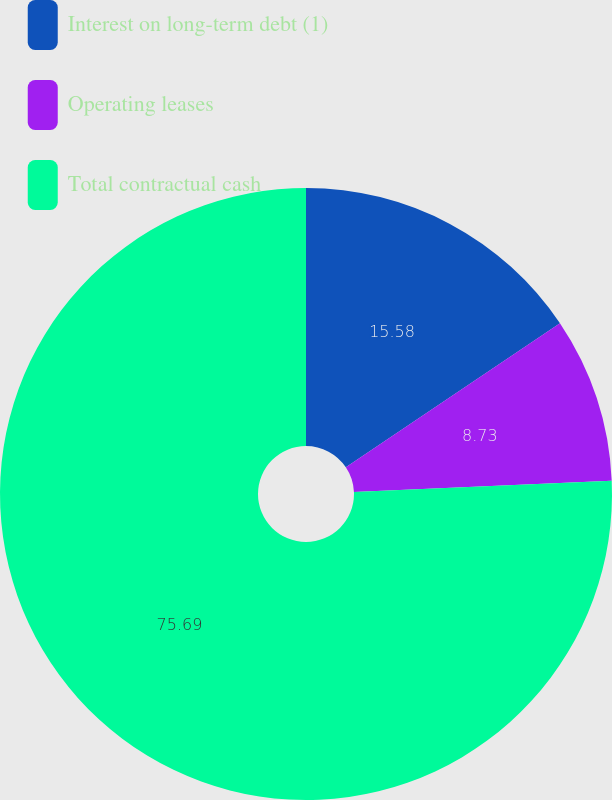<chart> <loc_0><loc_0><loc_500><loc_500><pie_chart><fcel>Interest on long-term debt (1)<fcel>Operating leases<fcel>Total contractual cash<nl><fcel>15.58%<fcel>8.73%<fcel>75.68%<nl></chart> 